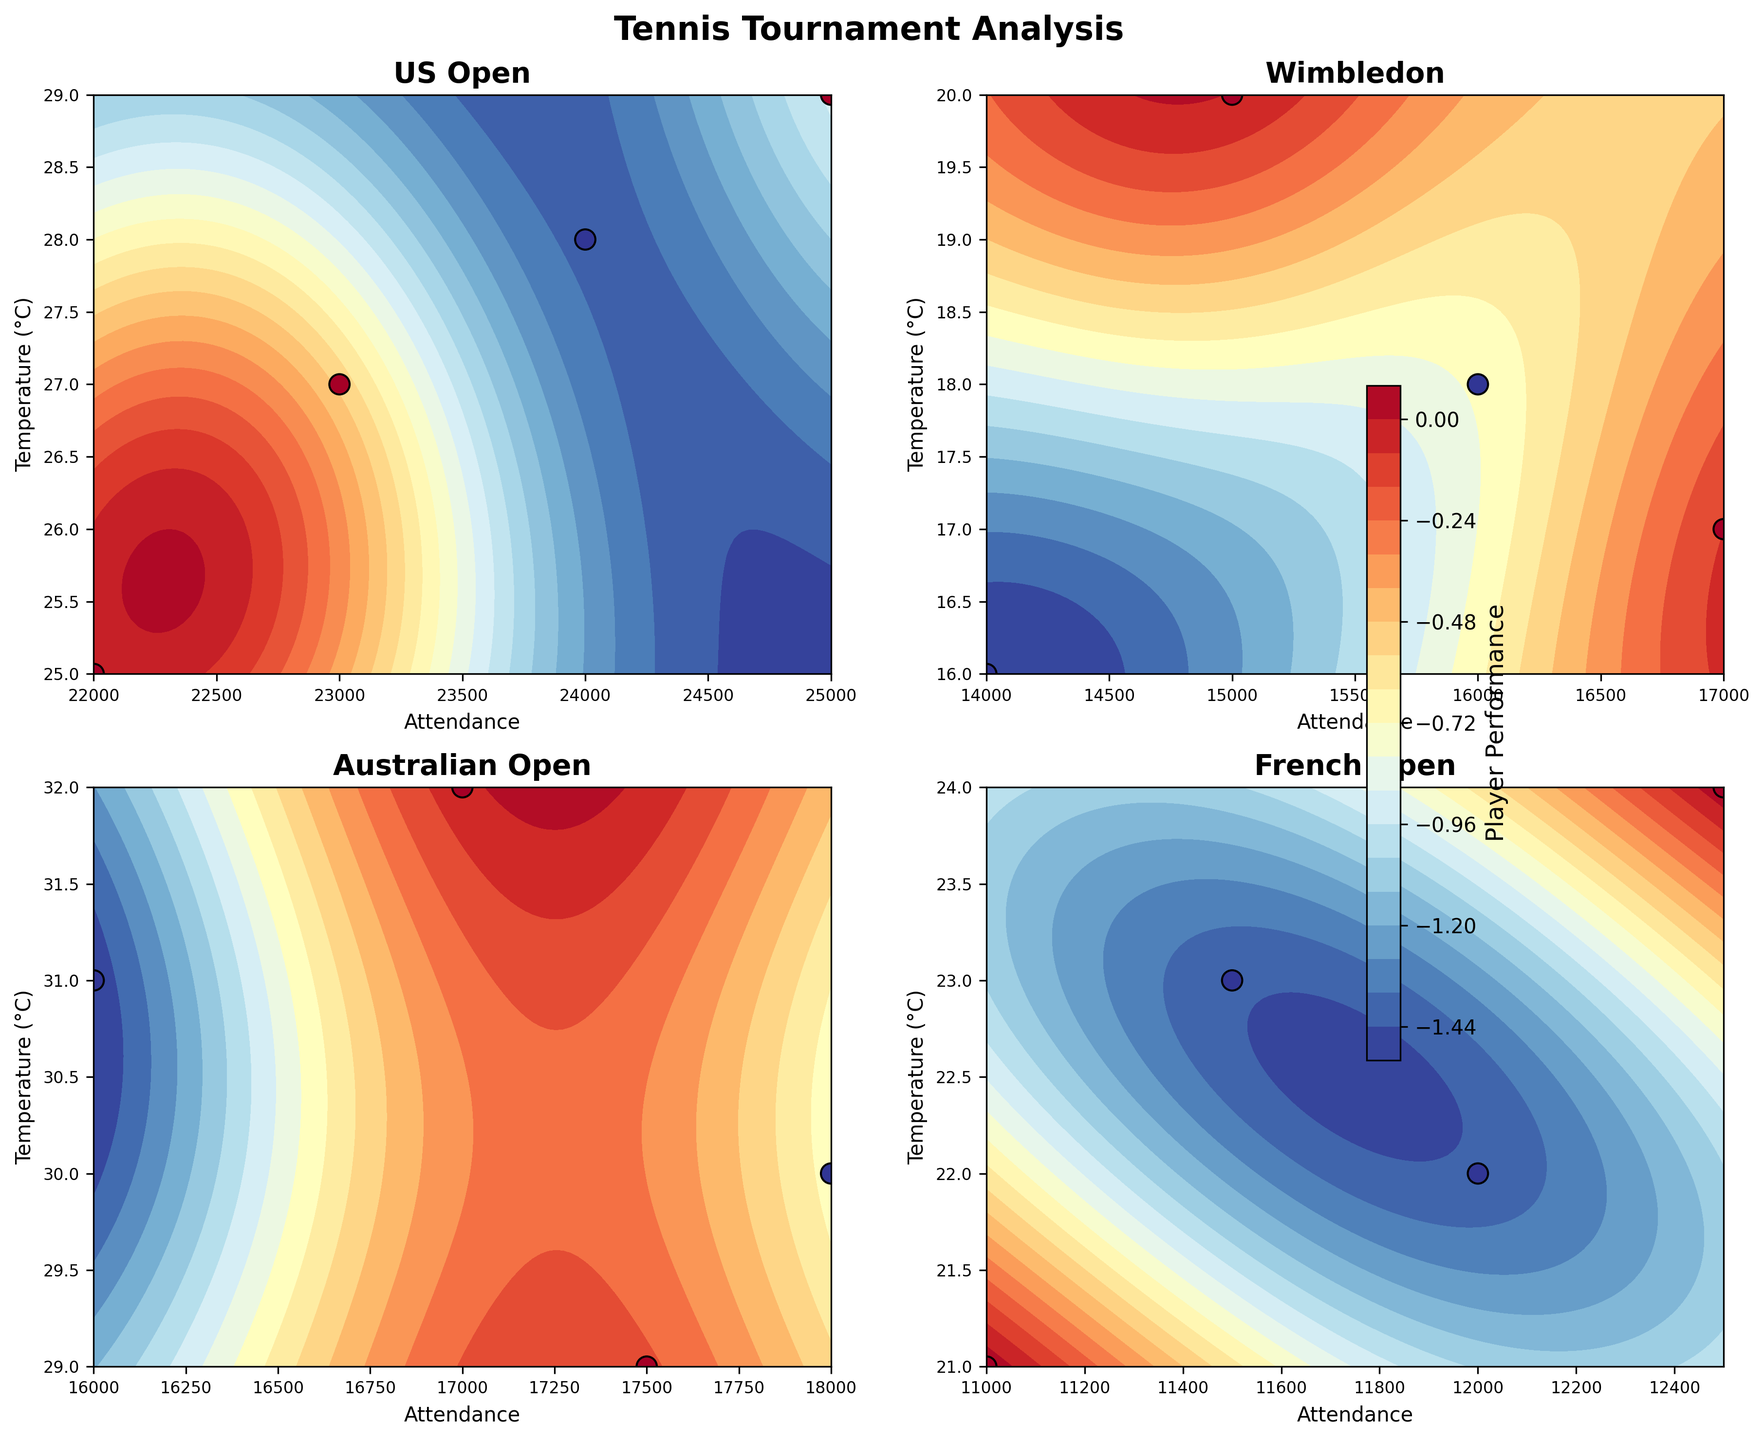What is the title of the figure? The title is usually displayed at the top of the figure. Here it is "Tennis Tournament Analysis".
Answer: Tennis Tournament Analysis How many subplots are there in the figure? The figure has four subplots. Each one is dedicated to a different tournament: US Open, Wimbledon, Australian Open, and French Open.
Answer: Four Which tournament had the highest attendance? By visually comparing the attendance scatter points across the four subplots, the US Open has the highest attendance.
Answer: US Open What is the color bar label on the figure? The label next to the color bar indicates the meaning of the different colors used in the contour plots. It is labeled "Player Performance".
Answer: Player Performance At the US Open, under what weather condition did the player perform best? By looking at the US Open subplot, the highest performance in player performance (dark colors) can be seen at temperatures around 27-29°C during clear weather.
Answer: 27-29°C clear Which tournament had the lowest player performance during rainy weather? To find the lowest performance, examine the subplots for rain conditions. Wimbledon and French Open had rain, but the French Open had visibly lower performance values.
Answer: French Open Compare the average attendance between Wimbledon and the Australian Open. Which is higher? Calculate the average of attendance points on the Wimbledon subplot and compare it similarly to the Australian Open subplot. Wimbledon has points around 14500-17000, while Australian Open has 16000-18000, hence the Australian Open has a slightly higher average.
Answer: Australian Open What weather condition generally resulted in the most consistent player performances? Consistency in performance is judged by the closeness of performance values across different data points. Visually, clear weather conditions across all subplots seem to have the most even distribution of player performance values.
Answer: Clear weather What is the overall trend of player performance concerning attendance for the US Open? By observing the subplot for the US Open contour plot: As attendance increases, player performance improves in many instances (more high-performance colors with higher attendance values).
Answer: Increases with attendance Which tournament had the most scattered player performance in different weather conditions? Examine the spread of player performance values across different weather (temperature) conditions in each subplot. Australian Open shows a wide range of performances from winning to losing across sunny weather conditions.
Answer: Australian Open 